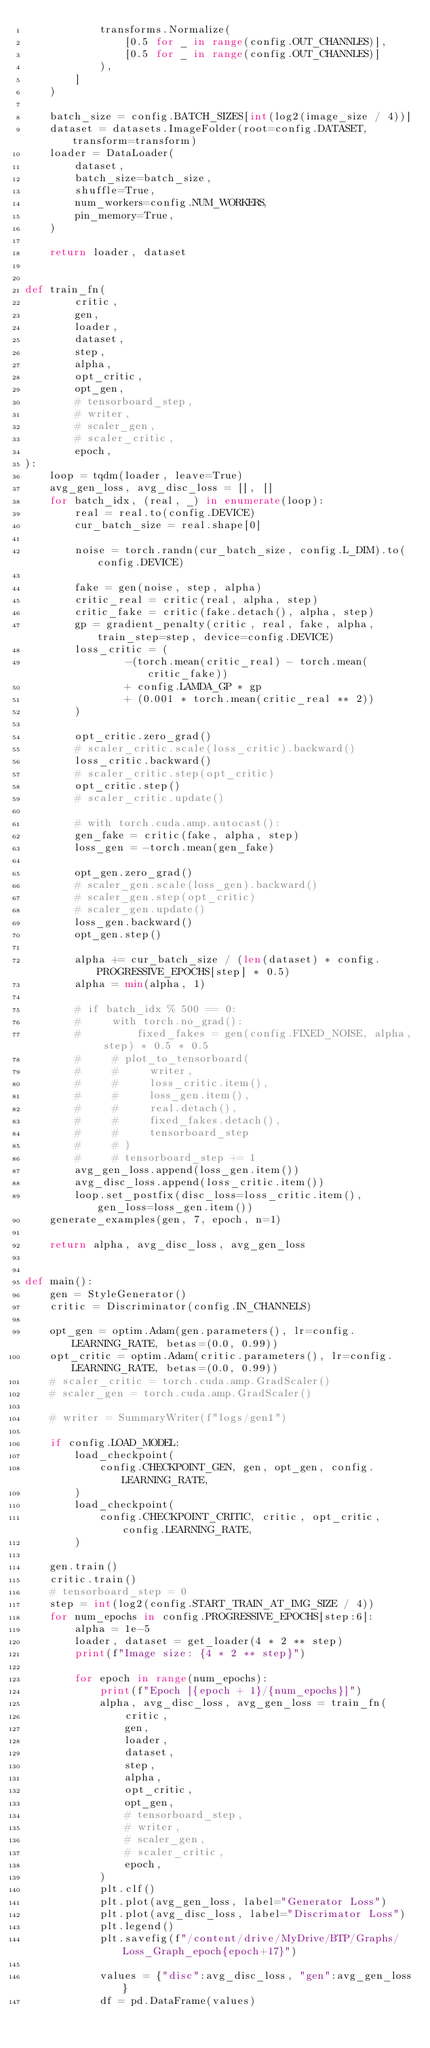<code> <loc_0><loc_0><loc_500><loc_500><_Python_>            transforms.Normalize(
                [0.5 for _ in range(config.OUT_CHANNLES)],
                [0.5 for _ in range(config.OUT_CHANNLES)]
            ),
        ]
    )

    batch_size = config.BATCH_SIZES[int(log2(image_size / 4))]
    dataset = datasets.ImageFolder(root=config.DATASET, transform=transform)
    loader = DataLoader(
        dataset,
        batch_size=batch_size,
        shuffle=True,
        num_workers=config.NUM_WORKERS,
        pin_memory=True,
    )

    return loader, dataset


def train_fn(
        critic,
        gen,
        loader,
        dataset,
        step,
        alpha,
        opt_critic,
        opt_gen,
        # tensorboard_step,
        # writer,
        # scaler_gen,
        # scaler_critic,
        epoch,
):
    loop = tqdm(loader, leave=True)
    avg_gen_loss, avg_disc_loss = [], []
    for batch_idx, (real, _) in enumerate(loop):
        real = real.to(config.DEVICE)
        cur_batch_size = real.shape[0]

        noise = torch.randn(cur_batch_size, config.L_DIM).to(config.DEVICE)

        fake = gen(noise, step, alpha)
        critic_real = critic(real, alpha, step)
        critic_fake = critic(fake.detach(), alpha, step)
        gp = gradient_penalty(critic, real, fake, alpha, train_step=step, device=config.DEVICE)
        loss_critic = (
                -(torch.mean(critic_real) - torch.mean(critic_fake))
                + config.LAMDA_GP * gp
                + (0.001 * torch.mean(critic_real ** 2))
        )

        opt_critic.zero_grad()
        # scaler_critic.scale(loss_critic).backward()
        loss_critic.backward()
        # scaler_critic.step(opt_critic)
        opt_critic.step()
        # scaler_critic.update()

        # with torch.cuda.amp.autocast():
        gen_fake = critic(fake, alpha, step)
        loss_gen = -torch.mean(gen_fake)

        opt_gen.zero_grad()
        # scaler_gen.scale(loss_gen).backward()
        # scaler_gen.step(opt_critic)
        # scaler_gen.update()
        loss_gen.backward()
        opt_gen.step()

        alpha += cur_batch_size / (len(dataset) * config.PROGRESSIVE_EPOCHS[step] * 0.5)
        alpha = min(alpha, 1)

        # if batch_idx % 500 == 0:
        #     with torch.no_grad():
        #         fixed_fakes = gen(config.FIXED_NOISE, alpha, step) * 0.5 * 0.5
        #     # plot_to_tensorboard(
        #     #     writer,
        #     #     loss_critic.item(),
        #     #     loss_gen.item(),
        #     #     real.detach(),
        #     #     fixed_fakes.detach(),
        #     #     tensorboard_step
        #     # )
        #     # tensorboard_step += 1
        avg_gen_loss.append(loss_gen.item())
        avg_disc_loss.append(loss_critic.item())
        loop.set_postfix(disc_loss=loss_critic.item(), gen_loss=loss_gen.item())
    generate_examples(gen, 7, epoch, n=1)

    return alpha, avg_disc_loss, avg_gen_loss


def main():
    gen = StyleGenerator()
    critic = Discriminator(config.IN_CHANNELS)

    opt_gen = optim.Adam(gen.parameters(), lr=config.LEARNING_RATE, betas=(0.0, 0.99))
    opt_critic = optim.Adam(critic.parameters(), lr=config.LEARNING_RATE, betas=(0.0, 0.99))
    # scaler_critic = torch.cuda.amp.GradScaler()
    # scaler_gen = torch.cuda.amp.GradScaler()

    # writer = SummaryWriter(f"logs/gen1")

    if config.LOAD_MODEL:
        load_checkpoint(
            config.CHECKPOINT_GEN, gen, opt_gen, config.LEARNING_RATE,
        )
        load_checkpoint(
            config.CHECKPOINT_CRITIC, critic, opt_critic, config.LEARNING_RATE,
        )

    gen.train()
    critic.train()
    # tensorboard_step = 0
    step = int(log2(config.START_TRAIN_AT_IMG_SIZE / 4))
    for num_epochs in config.PROGRESSIVE_EPOCHS[step:6]:
        alpha = 1e-5
        loader, dataset = get_loader(4 * 2 ** step)
        print(f"Image size: {4 * 2 ** step}")

        for epoch in range(num_epochs):
            print(f"Epoch [{epoch + 1}/{num_epochs}]")
            alpha, avg_disc_loss, avg_gen_loss = train_fn(
                critic,
                gen,
                loader,
                dataset,
                step,
                alpha,
                opt_critic,
                opt_gen,
                # tensorboard_step,
                # writer,
                # scaler_gen,
                # scaler_critic,
                epoch,
            )
            plt.clf()
            plt.plot(avg_gen_loss, label="Generator Loss")
            plt.plot(avg_disc_loss, label="Discrimator Loss")
            plt.legend()
            plt.savefig(f"/content/drive/MyDrive/BTP/Graphs/Loss_Graph_epoch{epoch+17}")

            values = {"disc":avg_disc_loss, "gen":avg_gen_loss}
            df = pd.DataFrame(values)</code> 